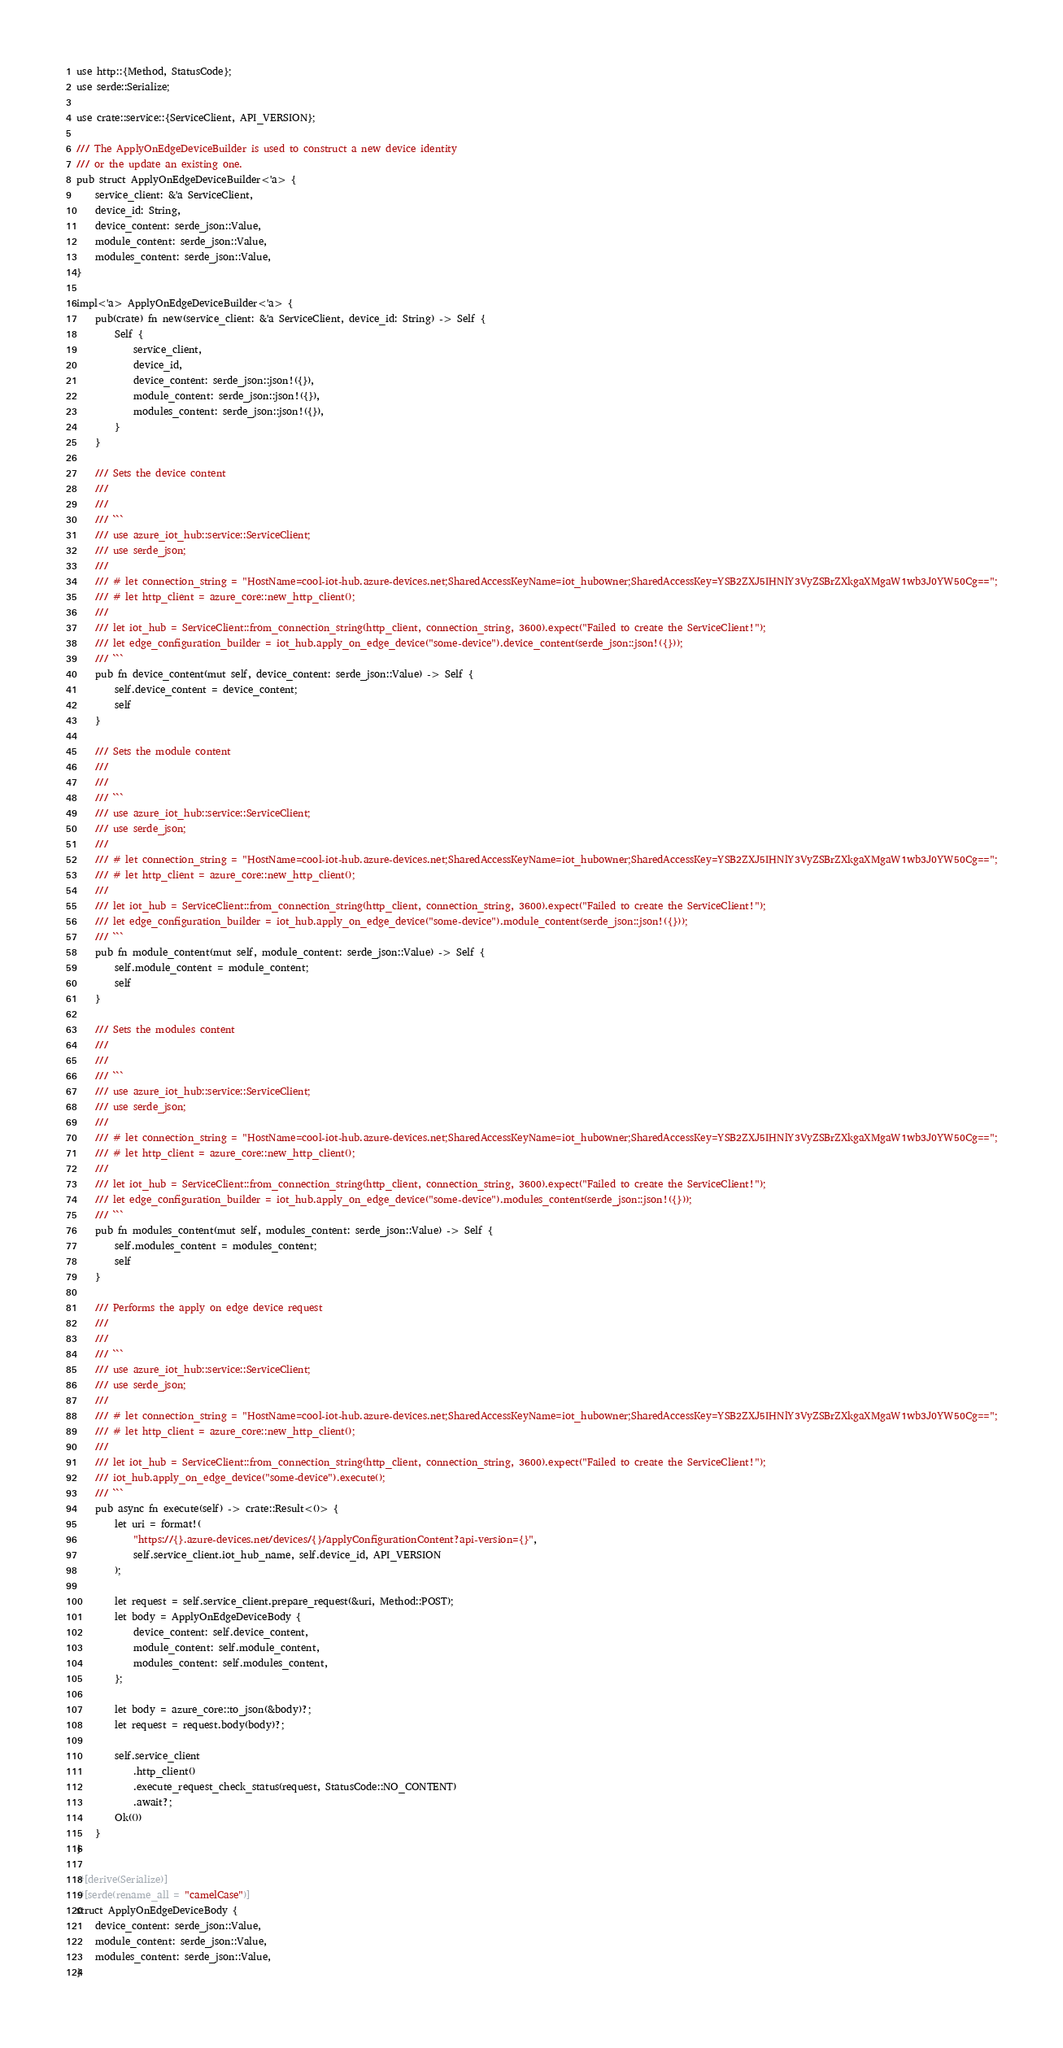Convert code to text. <code><loc_0><loc_0><loc_500><loc_500><_Rust_>use http::{Method, StatusCode};
use serde::Serialize;

use crate::service::{ServiceClient, API_VERSION};

/// The ApplyOnEdgeDeviceBuilder is used to construct a new device identity
/// or the update an existing one.
pub struct ApplyOnEdgeDeviceBuilder<'a> {
    service_client: &'a ServiceClient,
    device_id: String,
    device_content: serde_json::Value,
    module_content: serde_json::Value,
    modules_content: serde_json::Value,
}

impl<'a> ApplyOnEdgeDeviceBuilder<'a> {
    pub(crate) fn new(service_client: &'a ServiceClient, device_id: String) -> Self {
        Self {
            service_client,
            device_id,
            device_content: serde_json::json!({}),
            module_content: serde_json::json!({}),
            modules_content: serde_json::json!({}),
        }
    }

    /// Sets the device content
    ///
    ///
    /// ```
    /// use azure_iot_hub::service::ServiceClient;
    /// use serde_json;
    ///
    /// # let connection_string = "HostName=cool-iot-hub.azure-devices.net;SharedAccessKeyName=iot_hubowner;SharedAccessKey=YSB2ZXJ5IHNlY3VyZSBrZXkgaXMgaW1wb3J0YW50Cg==";
    /// # let http_client = azure_core::new_http_client();
    ///
    /// let iot_hub = ServiceClient::from_connection_string(http_client, connection_string, 3600).expect("Failed to create the ServiceClient!");
    /// let edge_configuration_builder = iot_hub.apply_on_edge_device("some-device").device_content(serde_json::json!({}));
    /// ```
    pub fn device_content(mut self, device_content: serde_json::Value) -> Self {
        self.device_content = device_content;
        self
    }

    /// Sets the module content
    ///
    ///
    /// ```
    /// use azure_iot_hub::service::ServiceClient;
    /// use serde_json;
    ///
    /// # let connection_string = "HostName=cool-iot-hub.azure-devices.net;SharedAccessKeyName=iot_hubowner;SharedAccessKey=YSB2ZXJ5IHNlY3VyZSBrZXkgaXMgaW1wb3J0YW50Cg==";
    /// # let http_client = azure_core::new_http_client();
    ///
    /// let iot_hub = ServiceClient::from_connection_string(http_client, connection_string, 3600).expect("Failed to create the ServiceClient!");
    /// let edge_configuration_builder = iot_hub.apply_on_edge_device("some-device").module_content(serde_json::json!({}));
    /// ```
    pub fn module_content(mut self, module_content: serde_json::Value) -> Self {
        self.module_content = module_content;
        self
    }

    /// Sets the modules content
    ///
    ///
    /// ```
    /// use azure_iot_hub::service::ServiceClient;
    /// use serde_json;
    ///
    /// # let connection_string = "HostName=cool-iot-hub.azure-devices.net;SharedAccessKeyName=iot_hubowner;SharedAccessKey=YSB2ZXJ5IHNlY3VyZSBrZXkgaXMgaW1wb3J0YW50Cg==";
    /// # let http_client = azure_core::new_http_client();
    ///
    /// let iot_hub = ServiceClient::from_connection_string(http_client, connection_string, 3600).expect("Failed to create the ServiceClient!");
    /// let edge_configuration_builder = iot_hub.apply_on_edge_device("some-device").modules_content(serde_json::json!({}));
    /// ```
    pub fn modules_content(mut self, modules_content: serde_json::Value) -> Self {
        self.modules_content = modules_content;
        self
    }

    /// Performs the apply on edge device request
    ///
    ///
    /// ```
    /// use azure_iot_hub::service::ServiceClient;
    /// use serde_json;
    ///
    /// # let connection_string = "HostName=cool-iot-hub.azure-devices.net;SharedAccessKeyName=iot_hubowner;SharedAccessKey=YSB2ZXJ5IHNlY3VyZSBrZXkgaXMgaW1wb3J0YW50Cg==";
    /// # let http_client = azure_core::new_http_client();
    ///
    /// let iot_hub = ServiceClient::from_connection_string(http_client, connection_string, 3600).expect("Failed to create the ServiceClient!");
    /// iot_hub.apply_on_edge_device("some-device").execute();
    /// ```
    pub async fn execute(self) -> crate::Result<()> {
        let uri = format!(
            "https://{}.azure-devices.net/devices/{}/applyConfigurationContent?api-version={}",
            self.service_client.iot_hub_name, self.device_id, API_VERSION
        );

        let request = self.service_client.prepare_request(&uri, Method::POST);
        let body = ApplyOnEdgeDeviceBody {
            device_content: self.device_content,
            module_content: self.module_content,
            modules_content: self.modules_content,
        };

        let body = azure_core::to_json(&body)?;
        let request = request.body(body)?;

        self.service_client
            .http_client()
            .execute_request_check_status(request, StatusCode::NO_CONTENT)
            .await?;
        Ok(())
    }
}

#[derive(Serialize)]
#[serde(rename_all = "camelCase")]
struct ApplyOnEdgeDeviceBody {
    device_content: serde_json::Value,
    module_content: serde_json::Value,
    modules_content: serde_json::Value,
}
</code> 